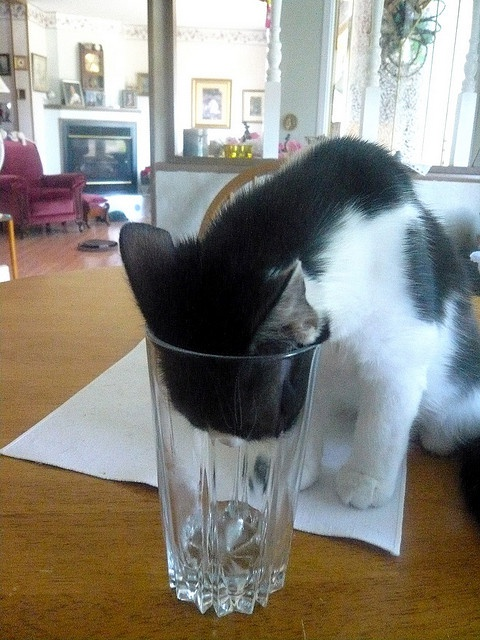Describe the objects in this image and their specific colors. I can see cat in gray, black, lightblue, and darkgray tones, dining table in gray, olive, tan, and maroon tones, cup in gray, black, and darkgray tones, chair in gray and purple tones, and tv in gray and darkgray tones in this image. 